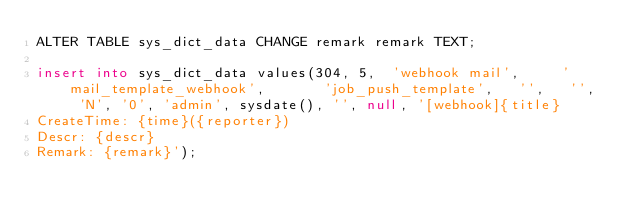<code> <loc_0><loc_0><loc_500><loc_500><_SQL_>ALTER TABLE sys_dict_data CHANGE remark remark TEXT;

insert into sys_dict_data values(304, 5,  'webhook mail',     'mail_template_webhook',       'job_push_template',   '',   '',  'N', '0', 'admin', sysdate(), '', null, '[webhook]{title}
CreateTime: {time}({reporter})
Descr: {descr}
Remark: {remark}');


</code> 